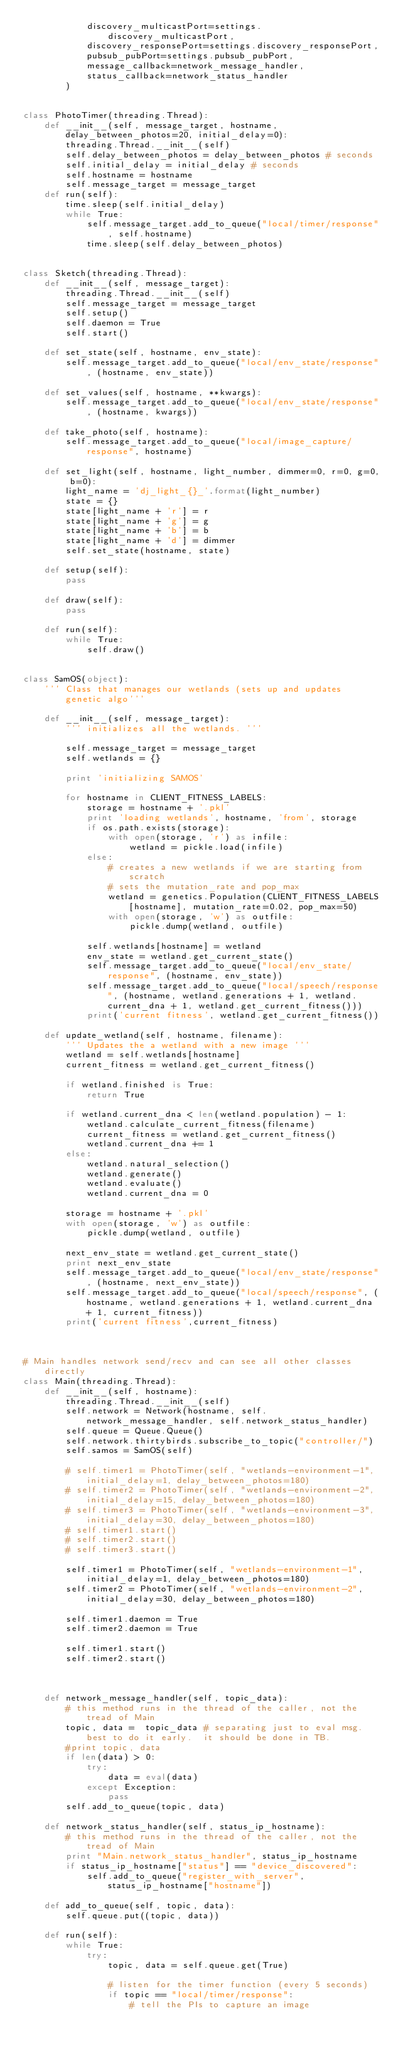<code> <loc_0><loc_0><loc_500><loc_500><_Python_>            discovery_multicastPort=settings.discovery_multicastPort,
            discovery_responsePort=settings.discovery_responsePort,
            pubsub_pubPort=settings.pubsub_pubPort,
            message_callback=network_message_handler,
            status_callback=network_status_handler
        )


class PhotoTimer(threading.Thread):
    def __init__(self, message_target, hostname, delay_between_photos=20, initial_delay=0):
        threading.Thread.__init__(self)
        self.delay_between_photos = delay_between_photos # seconds
        self.initial_delay = initial_delay # seconds
        self.hostname = hostname
        self.message_target = message_target
    def run(self):
        time.sleep(self.initial_delay)
        while True:
            self.message_target.add_to_queue("local/timer/response", self.hostname)
            time.sleep(self.delay_between_photos)


class Sketch(threading.Thread):
    def __init__(self, message_target):
        threading.Thread.__init__(self)
        self.message_target = message_target
        self.setup()
        self.daemon = True
        self.start()

    def set_state(self, hostname, env_state):
        self.message_target.add_to_queue("local/env_state/response", (hostname, env_state))

    def set_values(self, hostname, **kwargs):
        self.message_target.add_to_queue("local/env_state/response", (hostname, kwargs))

    def take_photo(self, hostname):
        self.message_target.add_to_queue("local/image_capture/response", hostname)

    def set_light(self, hostname, light_number, dimmer=0, r=0, g=0, b=0):
        light_name = 'dj_light_{}_'.format(light_number)
        state = {}
        state[light_name + 'r'] = r
        state[light_name + 'g'] = g
        state[light_name + 'b'] = b
        state[light_name + 'd'] = dimmer
        self.set_state(hostname, state)

    def setup(self):
        pass

    def draw(self):
        pass

    def run(self):
        while True:
            self.draw()


class SamOS(object):
    ''' Class that manages our wetlands (sets up and updates genetic algo'''

    def __init__(self, message_target):
        ''' initializes all the wetlands. '''

        self.message_target = message_target
        self.wetlands = {}

        print 'initializing SAMOS'

        for hostname in CLIENT_FITNESS_LABELS:
            storage = hostname + '.pkl'
            print 'loading wetlands', hostname, 'from', storage
            if os.path.exists(storage):
                with open(storage, 'r') as infile:
                    wetland = pickle.load(infile)
            else:
                # creates a new wetlands if we are starting from scratch
                # sets the mutation_rate and pop_max
                wetland = genetics.Population(CLIENT_FITNESS_LABELS[hostname], mutation_rate=0.02, pop_max=50)
                with open(storage, 'w') as outfile:
                    pickle.dump(wetland, outfile)

            self.wetlands[hostname] = wetland
            env_state = wetland.get_current_state()
            self.message_target.add_to_queue("local/env_state/response", (hostname, env_state))
            self.message_target.add_to_queue("local/speech/response", (hostname, wetland.generations + 1, wetland.current_dna + 1, wetland.get_current_fitness()))
            print('current fitness', wetland.get_current_fitness())

    def update_wetland(self, hostname, filename):
        ''' Updates the a wetland with a new image '''
        wetland = self.wetlands[hostname]
        current_fitness = wetland.get_current_fitness()

        if wetland.finished is True:
            return True

        if wetland.current_dna < len(wetland.population) - 1:
            wetland.calculate_current_fitness(filename)
            current_fitness = wetland.get_current_fitness()
            wetland.current_dna += 1
        else:
            wetland.natural_selection()
            wetland.generate()
            wetland.evaluate()
            wetland.current_dna = 0

        storage = hostname + '.pkl'
        with open(storage, 'w') as outfile:
            pickle.dump(wetland, outfile)

        next_env_state = wetland.get_current_state()
        print next_env_state
        self.message_target.add_to_queue("local/env_state/response", (hostname, next_env_state))
        self.message_target.add_to_queue("local/speech/response", (hostname, wetland.generations + 1, wetland.current_dna + 1, current_fitness))
        print('current fitness',current_fitness)



# Main handles network send/recv and can see all other classes directly
class Main(threading.Thread):
    def __init__(self, hostname):
        threading.Thread.__init__(self)
        self.network = Network(hostname, self.network_message_handler, self.network_status_handler)
        self.queue = Queue.Queue()
        self.network.thirtybirds.subscribe_to_topic("controller/")
        self.samos = SamOS(self)

        # self.timer1 = PhotoTimer(self, "wetlands-environment-1", initial_delay=1, delay_between_photos=180)
        # self.timer2 = PhotoTimer(self, "wetlands-environment-2", initial_delay=15, delay_between_photos=180)
        # self.timer3 = PhotoTimer(self, "wetlands-environment-3", initial_delay=30, delay_between_photos=180)
        # self.timer1.start()
        # self.timer2.start()
        # self.timer3.start()

        self.timer1 = PhotoTimer(self, "wetlands-environment-1", initial_delay=1, delay_between_photos=180)
        self.timer2 = PhotoTimer(self, "wetlands-environment-2", initial_delay=30, delay_between_photos=180)

        self.timer1.daemon = True
        self.timer2.daemon = True

        self.timer1.start()
        self.timer2.start()



    def network_message_handler(self, topic_data):
        # this method runs in the thread of the caller, not the tread of Main
        topic, data =  topic_data # separating just to eval msg.  best to do it early.  it should be done in TB.
        #print topic, data
        if len(data) > 0:
            try:
                data = eval(data)
            except Exception:
                pass
        self.add_to_queue(topic, data)

    def network_status_handler(self, status_ip_hostname):
        # this method runs in the thread of the caller, not the tread of Main
        print "Main.network_status_handler", status_ip_hostname
        if status_ip_hostname["status"] == "device_discovered":
            self.add_to_queue("register_with_server", status_ip_hostname["hostname"])

    def add_to_queue(self, topic, data):
        self.queue.put((topic, data))

    def run(self):
        while True:
            try:
                topic, data = self.queue.get(True)

                # listen for the timer function (every 5 seconds)
                if topic == "local/timer/response":
                    # tell the PIs to capture an image</code> 